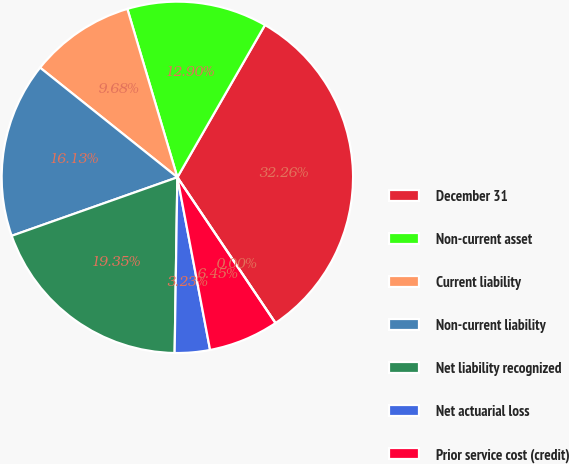Convert chart. <chart><loc_0><loc_0><loc_500><loc_500><pie_chart><fcel>December 31<fcel>Non-current asset<fcel>Current liability<fcel>Non-current liability<fcel>Net liability recognized<fcel>Net actuarial loss<fcel>Prior service cost (credit)<fcel>Total amount recognized<nl><fcel>32.26%<fcel>12.9%<fcel>9.68%<fcel>16.13%<fcel>19.35%<fcel>3.23%<fcel>6.45%<fcel>0.0%<nl></chart> 